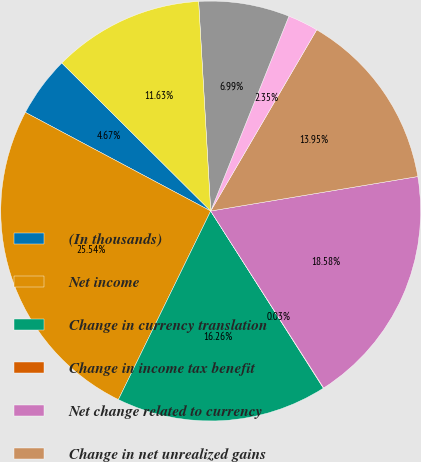<chart> <loc_0><loc_0><loc_500><loc_500><pie_chart><fcel>(In thousands)<fcel>Net income<fcel>Change in currency translation<fcel>Change in income tax benefit<fcel>Net change related to currency<fcel>Change in net unrealized gains<fcel>Reclassification adjustments<fcel>Net change related to cash<fcel>Net change related to<nl><fcel>4.67%<fcel>25.54%<fcel>16.26%<fcel>0.03%<fcel>18.58%<fcel>13.95%<fcel>2.35%<fcel>6.99%<fcel>11.63%<nl></chart> 